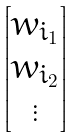Convert formula to latex. <formula><loc_0><loc_0><loc_500><loc_500>\begin{bmatrix} w _ { i _ { 1 } } \\ w _ { i _ { 2 } } \\ \vdots \end{bmatrix}</formula> 